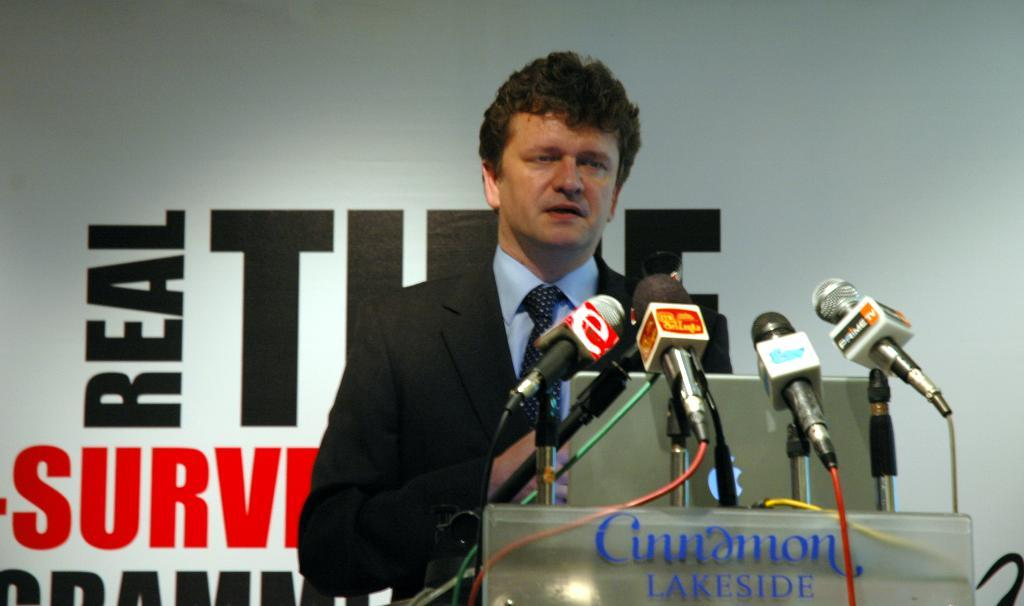What is the man in the image doing? The man is standing in front of a laptop. What objects are present near the man? There are microphones on a podium in front of the man. What can be seen in the background of the image? There is a hoarding visible in the background of the image. How many giants are visible in the image? There are no giants present in the image. What type of tank is being used by the man in the image? There is no tank present in the image; the man is standing in front of a laptop and microphones on a podium. 